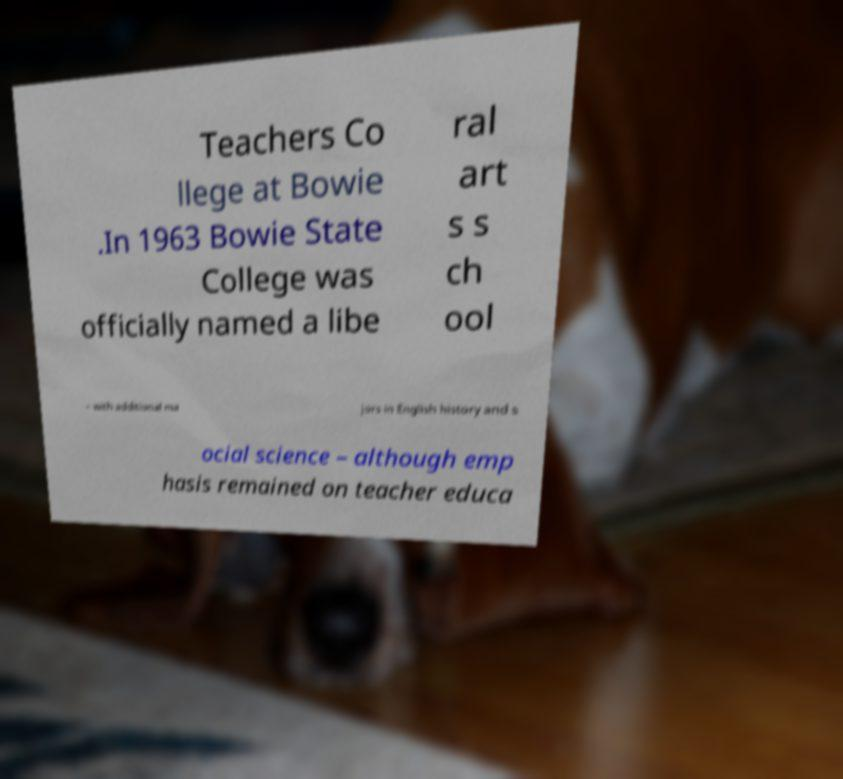What messages or text are displayed in this image? I need them in a readable, typed format. Teachers Co llege at Bowie .In 1963 Bowie State College was officially named a libe ral art s s ch ool – with additional ma jors in English history and s ocial science – although emp hasis remained on teacher educa 